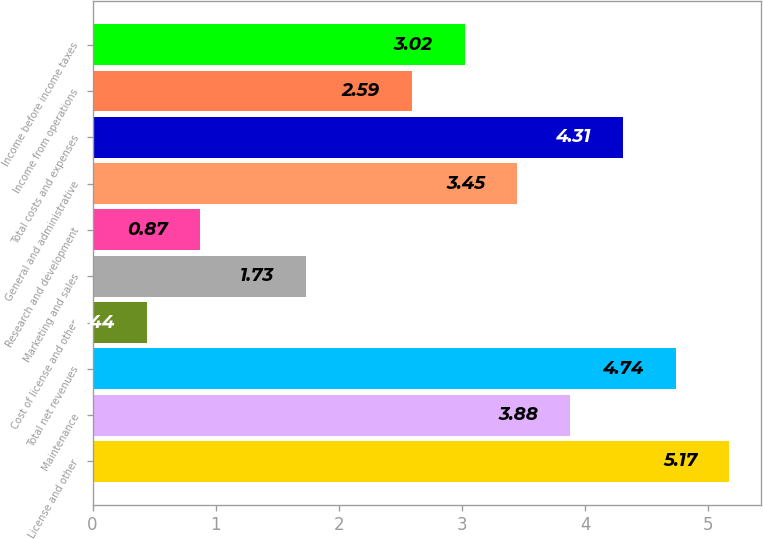Convert chart to OTSL. <chart><loc_0><loc_0><loc_500><loc_500><bar_chart><fcel>License and other<fcel>Maintenance<fcel>Total net revenues<fcel>Cost of license and other<fcel>Marketing and sales<fcel>Research and development<fcel>General and administrative<fcel>Total costs and expenses<fcel>Income from operations<fcel>Income before income taxes<nl><fcel>5.17<fcel>3.88<fcel>4.74<fcel>0.44<fcel>1.73<fcel>0.87<fcel>3.45<fcel>4.31<fcel>2.59<fcel>3.02<nl></chart> 